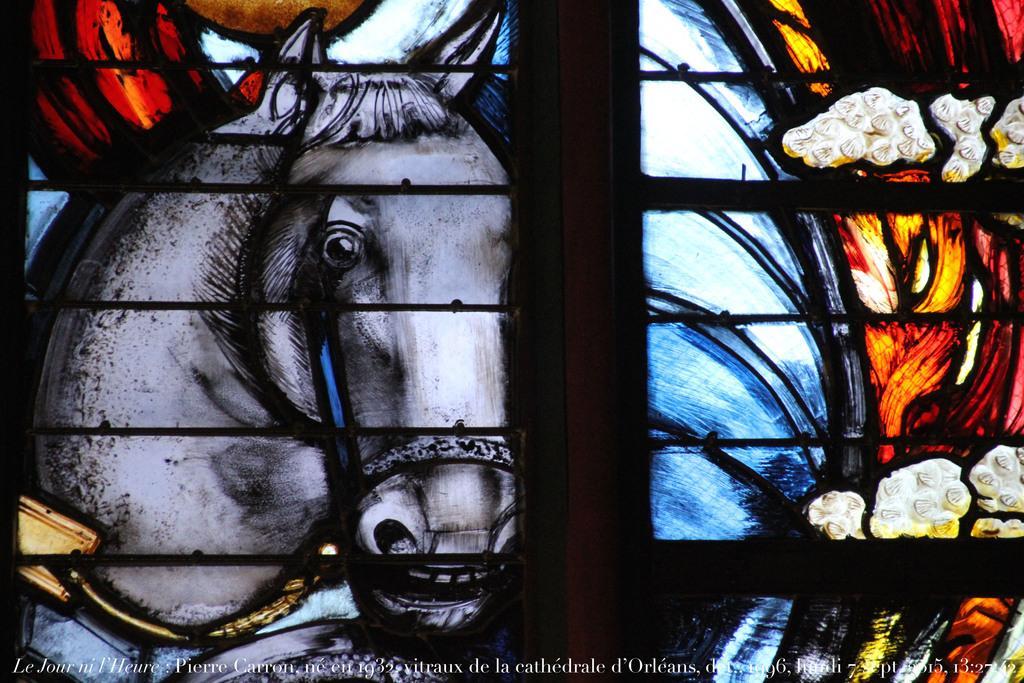Describe this image in one or two sentences. In this image, we can see window, grills and glass painting. At the bottom of the image, we can see watermark. 